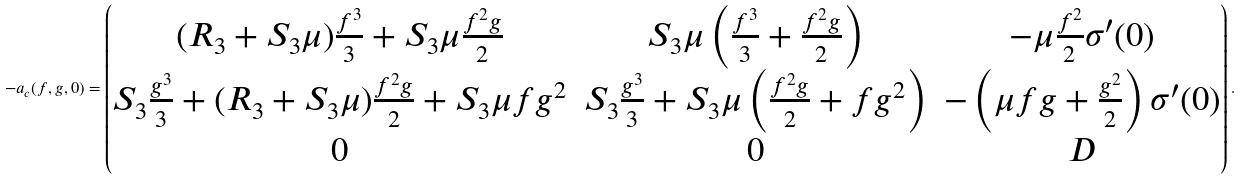<formula> <loc_0><loc_0><loc_500><loc_500>- a _ { c } ( f , g , 0 ) = \begin{pmatrix} ( R _ { 3 } + S _ { 3 } \mu ) \frac { f ^ { 3 } } { 3 } + S _ { 3 } \mu \frac { f ^ { 2 } g } { 2 } & S _ { 3 } \mu \left ( \frac { f ^ { 3 } } { 3 } + \frac { f ^ { 2 } g } { 2 } \right ) & - \mu \frac { f ^ { 2 } } { 2 } \sigma ^ { \prime } ( 0 ) \\ S _ { 3 } \frac { g ^ { 3 } } { 3 } + ( R _ { 3 } + S _ { 3 } \mu ) \frac { f ^ { 2 } g } { 2 } + S _ { 3 } \mu f g ^ { 2 } & S _ { 3 } \frac { g ^ { 3 } } { 3 } + S _ { 3 } \mu \left ( \frac { f ^ { 2 } g } { 2 } + f g ^ { 2 } \right ) & - \left ( \mu f g + \frac { g ^ { 2 } } { 2 } \right ) \sigma ^ { \prime } ( 0 ) \\ 0 & 0 & D \end{pmatrix} .</formula> 